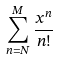<formula> <loc_0><loc_0><loc_500><loc_500>\sum _ { n = N } ^ { M } \frac { x ^ { n } } { n ! }</formula> 